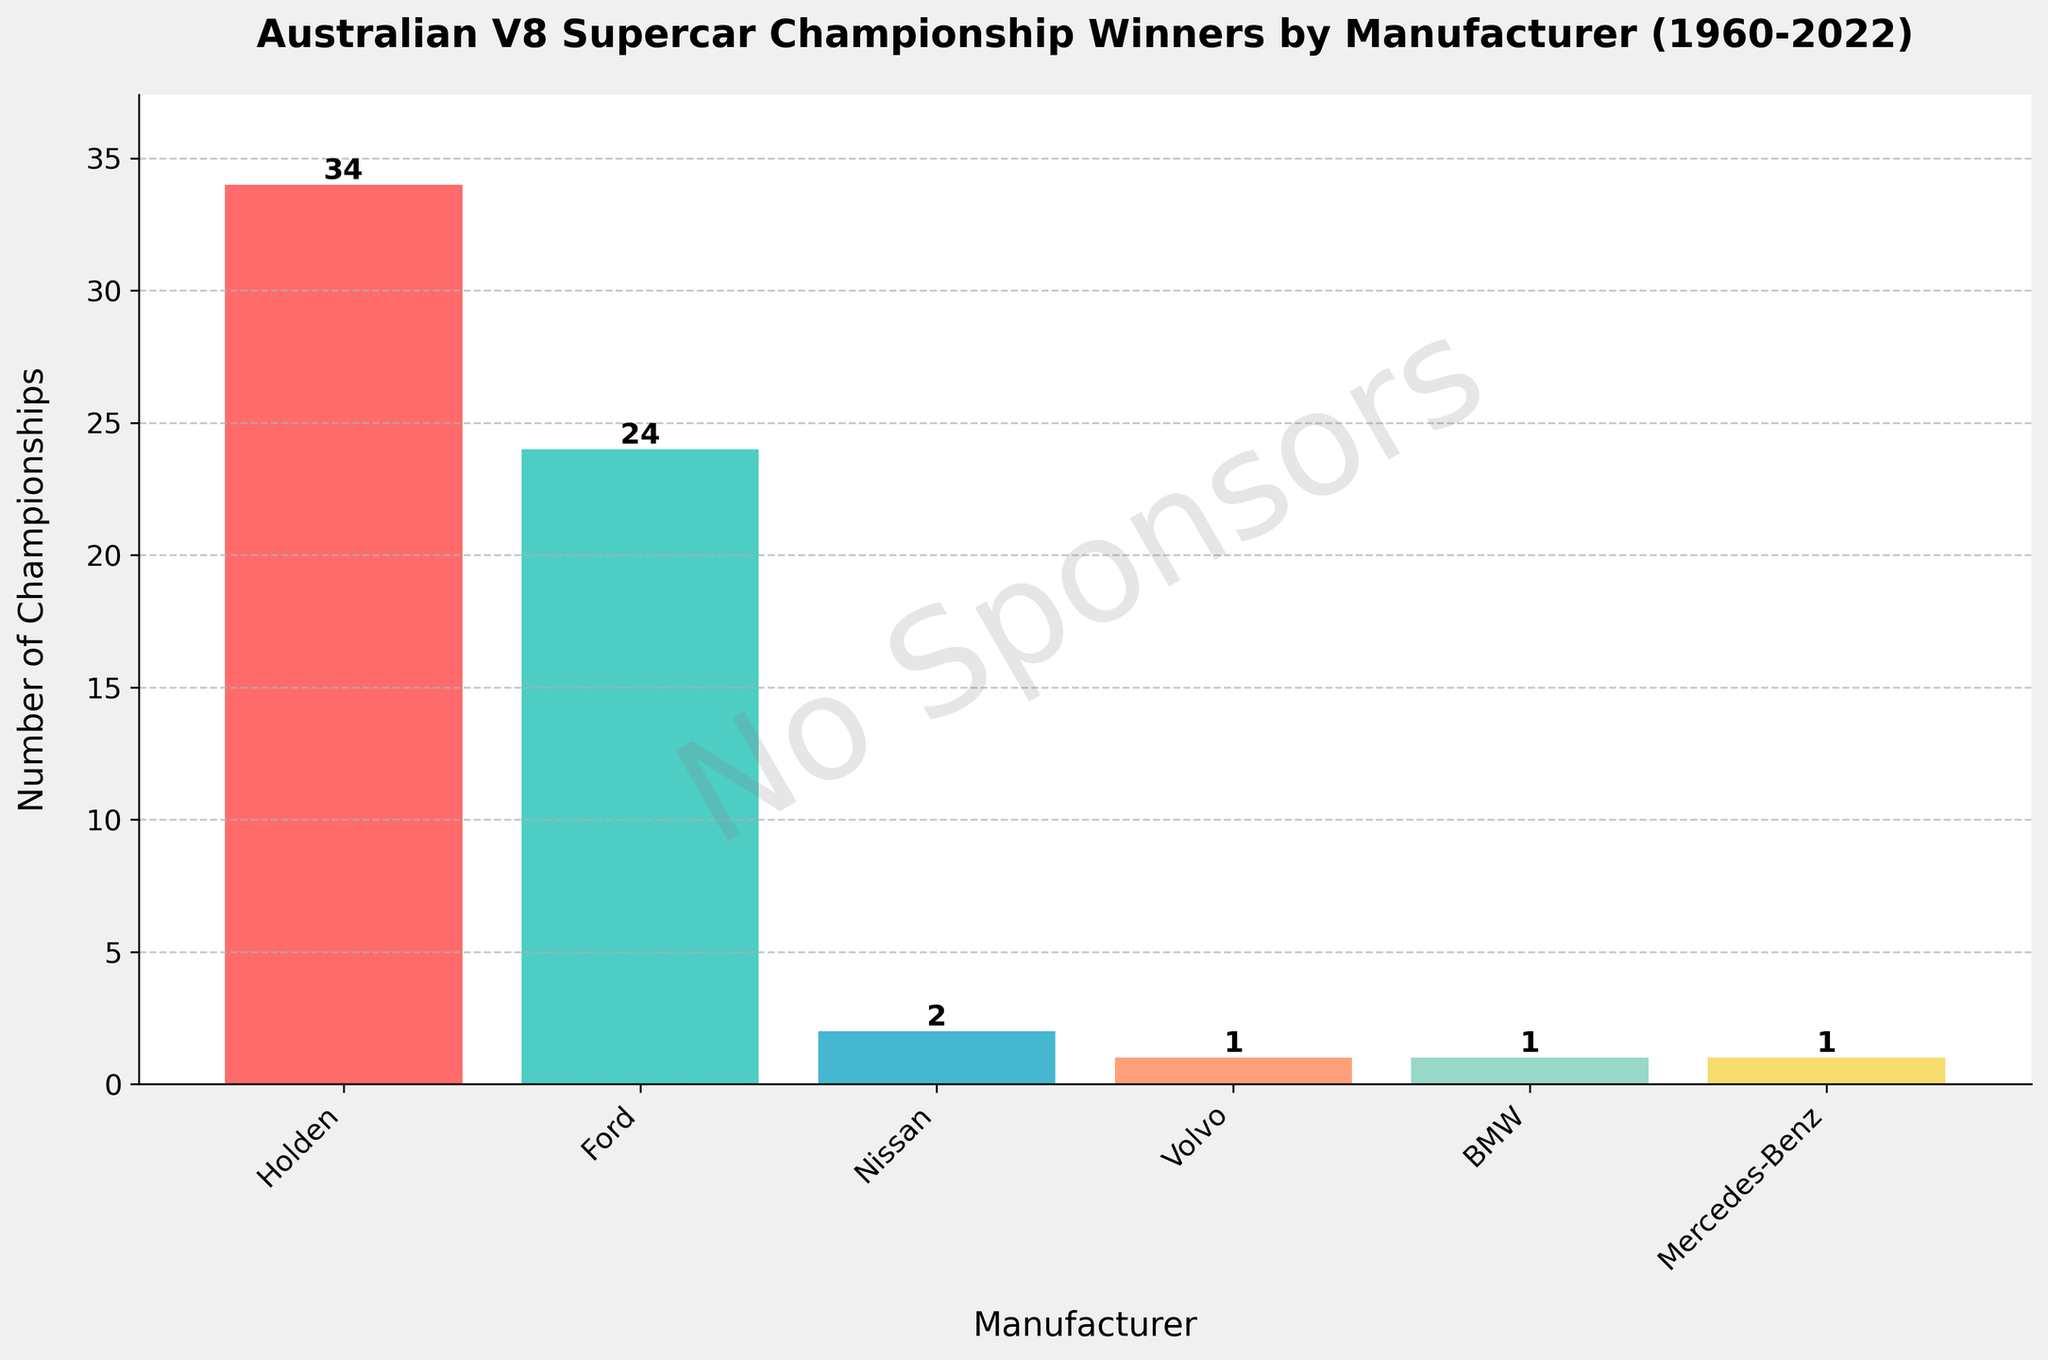Which manufacturer has won the most championships? To find the manufacturer with the most championships, we look for the tallest bar in the bar chart. The bar representing Holden reaches the highest on the chart, indicating it has won the most championships.
Answer: Holden How many total championships have Ford and Holden won together? To find the total number of championships won by Ford and Holden together, we add the number of championships won by each. Holden has 34 and Ford has 24. Adding these gives us 34 + 24 = 58.
Answer: 58 Which manufacturer has won more championships, Nissan or BMW? To determine which manufacturer has more championships between Nissan and BMW, we compare the height of their respective bars. The bar for Nissan is higher than the bar for BMW, indicating Nissan has more championships.
Answer: Nissan How many manufacturers have won exactly one championship? To find the number of manufacturers that have won exactly one championship, we look for bars that reach the height corresponding to the value 1. These bars belong to Volvo, BMW, and Mercedes-Benz, so there are 3 such manufacturers.
Answer: 3 What is the difference in championship wins between Holden and Ford? To find the difference in championship wins between Holden and Ford, we subtract the number of championships won by Ford from those won by Holden. Holden has 34 championships and Ford has 24, so the difference is 34 - 24 = 10.
Answer: 10 What is the average number of championships won by all the manufacturers? To find the average number of championships won by all manufacturers, we sum up the total championships and divide by the number of manufacturers. The sum of championships is 34 + 24 + 2 + 1 + 1 + 1 = 63, and there are 6 manufacturers. The average is 63 / 6 = 10.5.
Answer: 10.5 Which manufacturer has the lowest number of championships, and how many is it? To find the manufacturer with the lowest number of championships and how many that is, we look for the bar that is the shortest in height. The shortest bars represent Volvo, BMW, and Mercedes-Benz, each with 1 championship.
Answer: Volvo, BMW, and Mercedes-Benz, 1 If Nissan won 3 more championships, what would their total be and how would their ranking change? If Nissan won 3 more championships, we add 3 to their current 2, which would give them 5. This would place them above Volvo, BMW, and Mercedes-Benz but still below Ford and Holden.
Answer: 5, fourth place What percentage of the total championships were won by manufacturers other than Holden and Ford? First, find the total championships by all manufacturers, which is 63. Then, sum the championships won by Holden (34) and Ford (24), which is 58. Subtract to find championships by other manufacturers: 63 - 58 = 5. Finally, calculate the percentage: (5 / 63) * 100 ≈ 7.94%.
Answer: 7.94% Is there a significant visual difference in the heights of the bars for Holden and any other manufacturer? To determine if there is a significant visual difference, we compare the height of Holden's bar with that of the other manufacturers. The bar for Holden is significantly taller than all other bars, indicating a large difference in the number of championships won.
Answer: Yes 